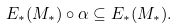Convert formula to latex. <formula><loc_0><loc_0><loc_500><loc_500>E _ { * } ( M _ { * } ) \circ \alpha \subseteq E _ { * } ( M _ { * } ) .</formula> 